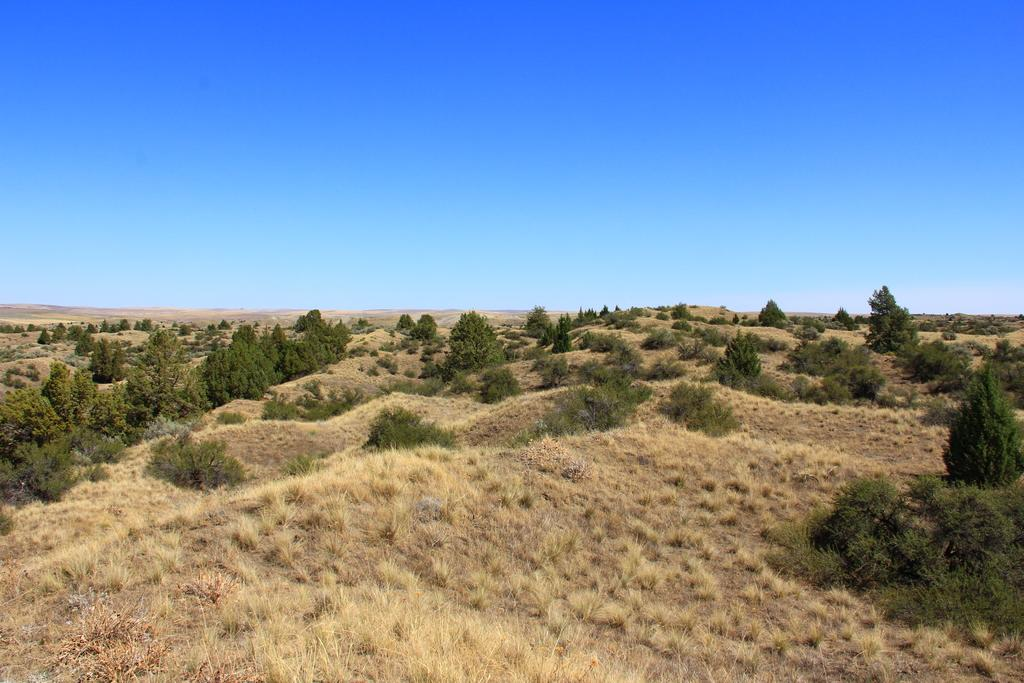What type of vegetation is present in the image? There is grass, plants, and trees in the image. What can be seen in the background of the image? The sky is visible in the background of the image. What type of music is the band playing in the image? There is no band present in the image, so it is not possible to determine what type of music might be played. 